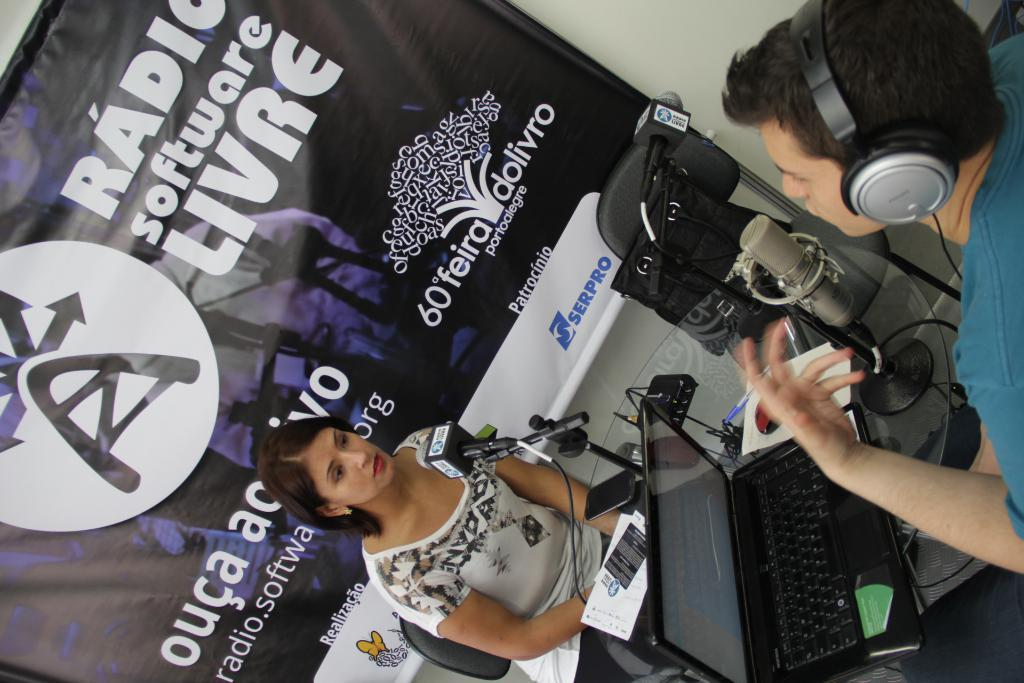<image>
Relay a brief, clear account of the picture shown. A man and woman are talking together on a radio show with microphones and the background wording includes SERPRO and a tree with 60 feira dolivro. 